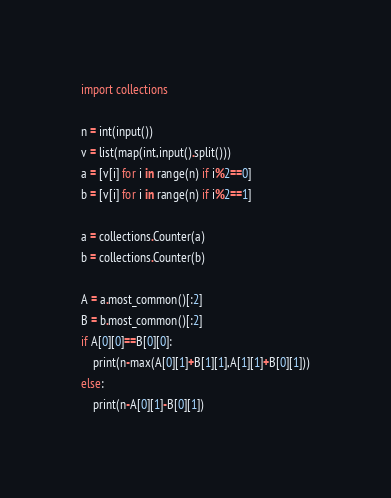Convert code to text. <code><loc_0><loc_0><loc_500><loc_500><_Python_>import collections

n = int(input())
v = list(map(int,input().split()))
a = [v[i] for i in range(n) if i%2==0]
b = [v[i] for i in range(n) if i%2==1]

a = collections.Counter(a)
b = collections.Counter(b)

A = a.most_common()[:2]
B = b.most_common()[:2]
if A[0][0]==B[0][0]:
    print(n-max(A[0][1]+B[1][1],A[1][1]+B[0][1]))
else:
    print(n-A[0][1]-B[0][1])</code> 